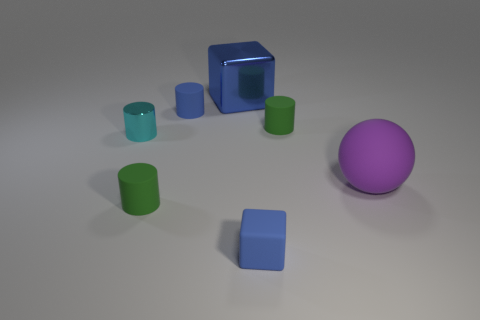Subtract all green cubes. How many green cylinders are left? 2 Subtract all small blue rubber cylinders. How many cylinders are left? 3 Subtract all blue cylinders. How many cylinders are left? 3 Add 2 big purple matte things. How many objects exist? 9 Subtract all cylinders. How many objects are left? 3 Subtract all brown cylinders. Subtract all gray cubes. How many cylinders are left? 4 Subtract all metal cylinders. Subtract all tiny green objects. How many objects are left? 4 Add 1 rubber objects. How many rubber objects are left? 6 Add 7 small purple shiny balls. How many small purple shiny balls exist? 7 Subtract 0 purple cylinders. How many objects are left? 7 